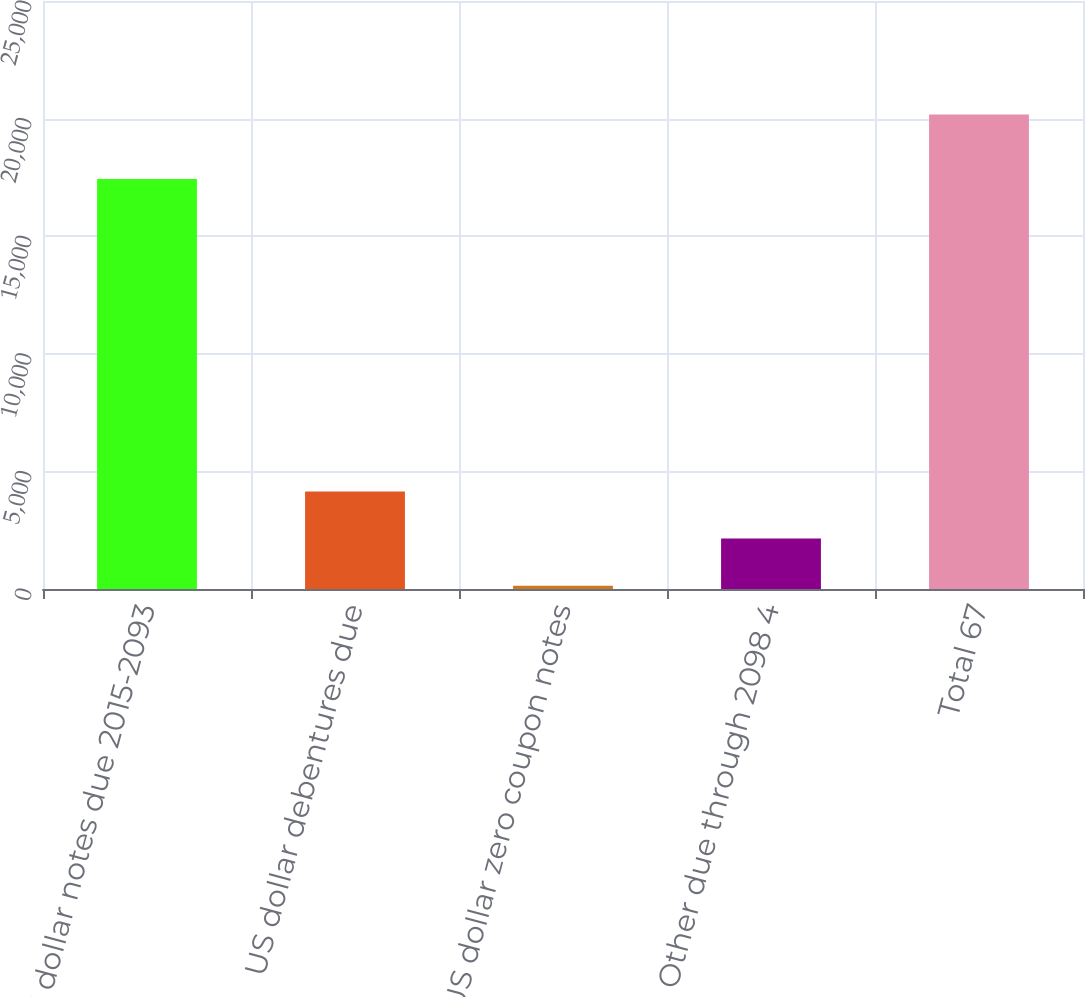<chart> <loc_0><loc_0><loc_500><loc_500><bar_chart><fcel>US dollar notes due 2015-2093<fcel>US dollar debentures due<fcel>US dollar zero coupon notes<fcel>Other due through 2098 4<fcel>Total 67<nl><fcel>17427<fcel>4146<fcel>138<fcel>2142<fcel>20178<nl></chart> 